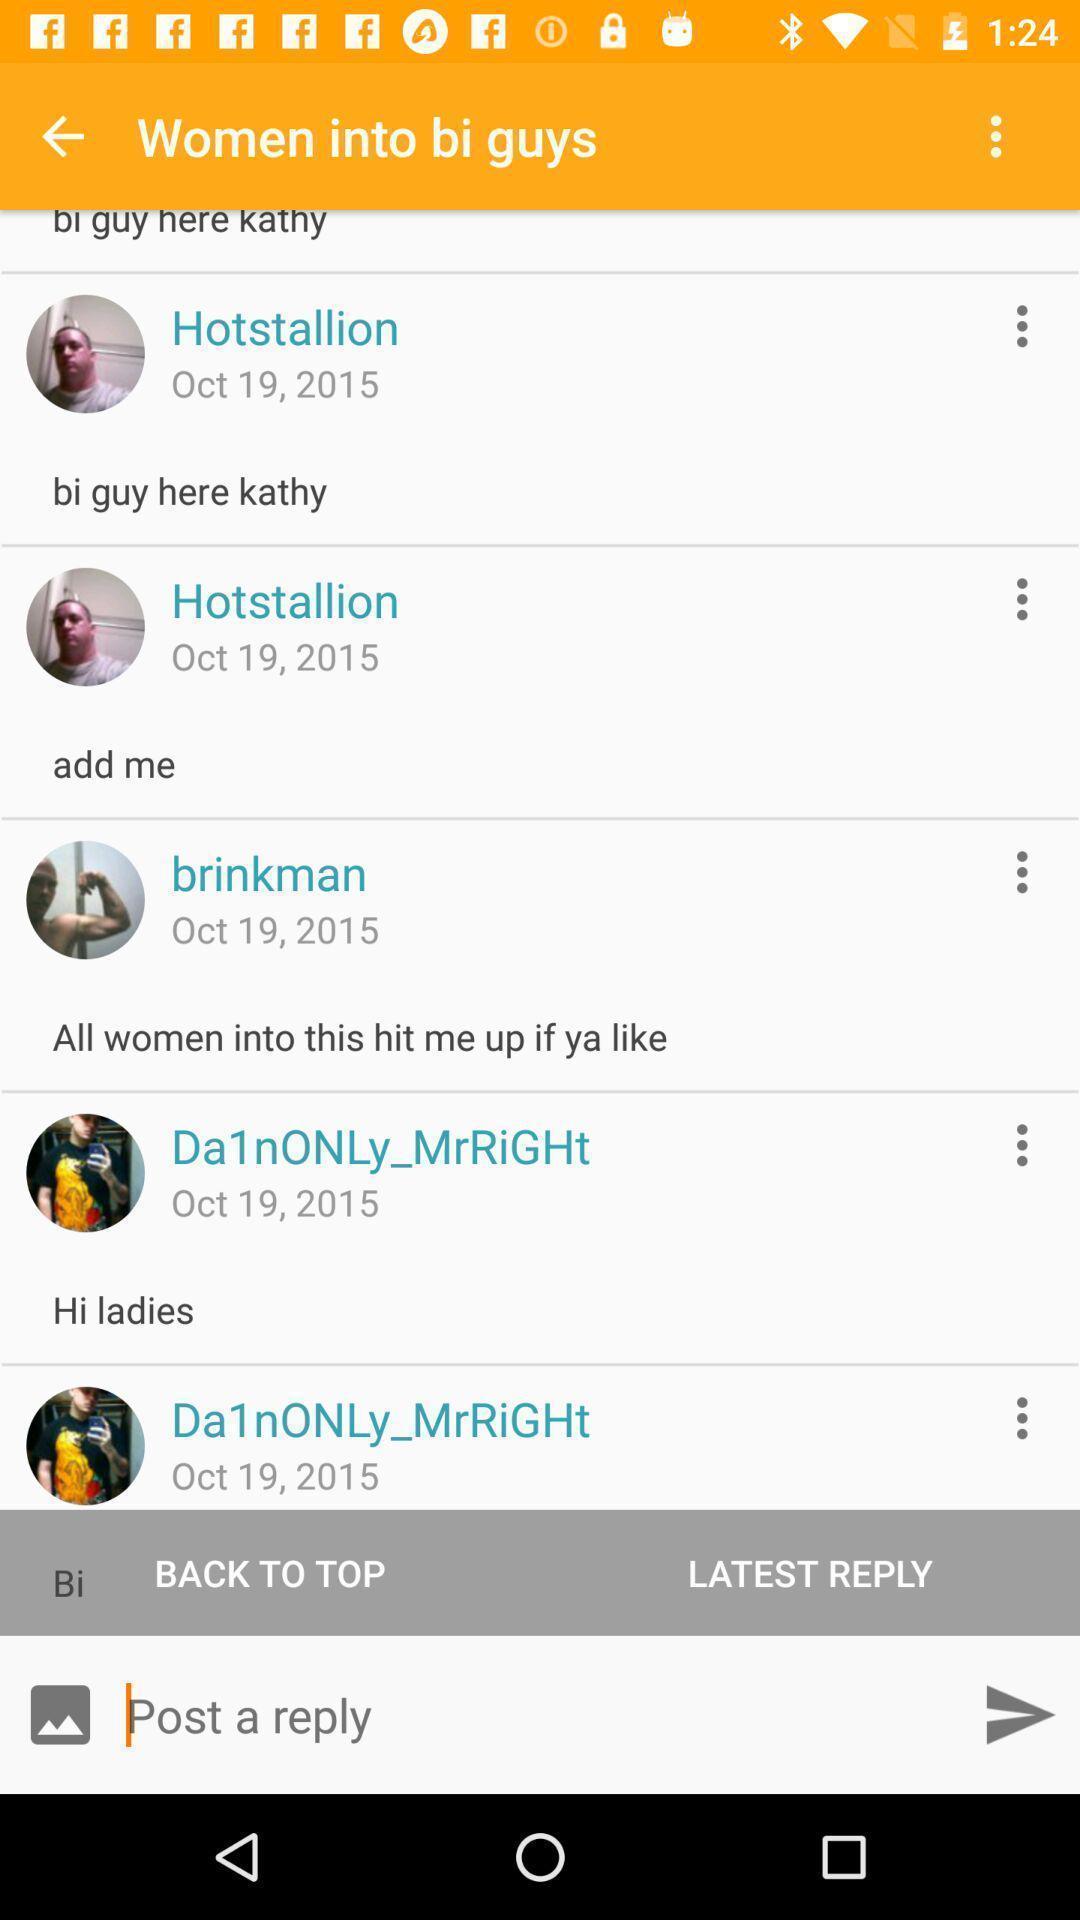Give me a narrative description of this picture. Screen shows a reply option. 